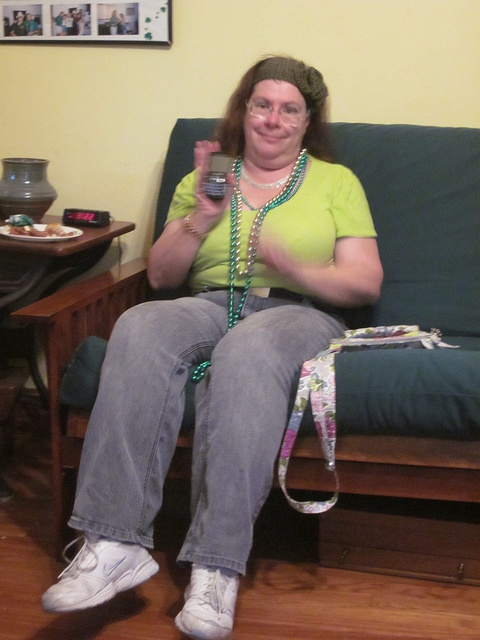Describe the objects in this image and their specific colors. I can see people in darkgray, gray, and lightpink tones, couch in darkgray, purple, and black tones, handbag in darkgray, black, gray, and maroon tones, vase in darkgray, gray, and black tones, and dining table in darkgray, maroon, black, gray, and brown tones in this image. 